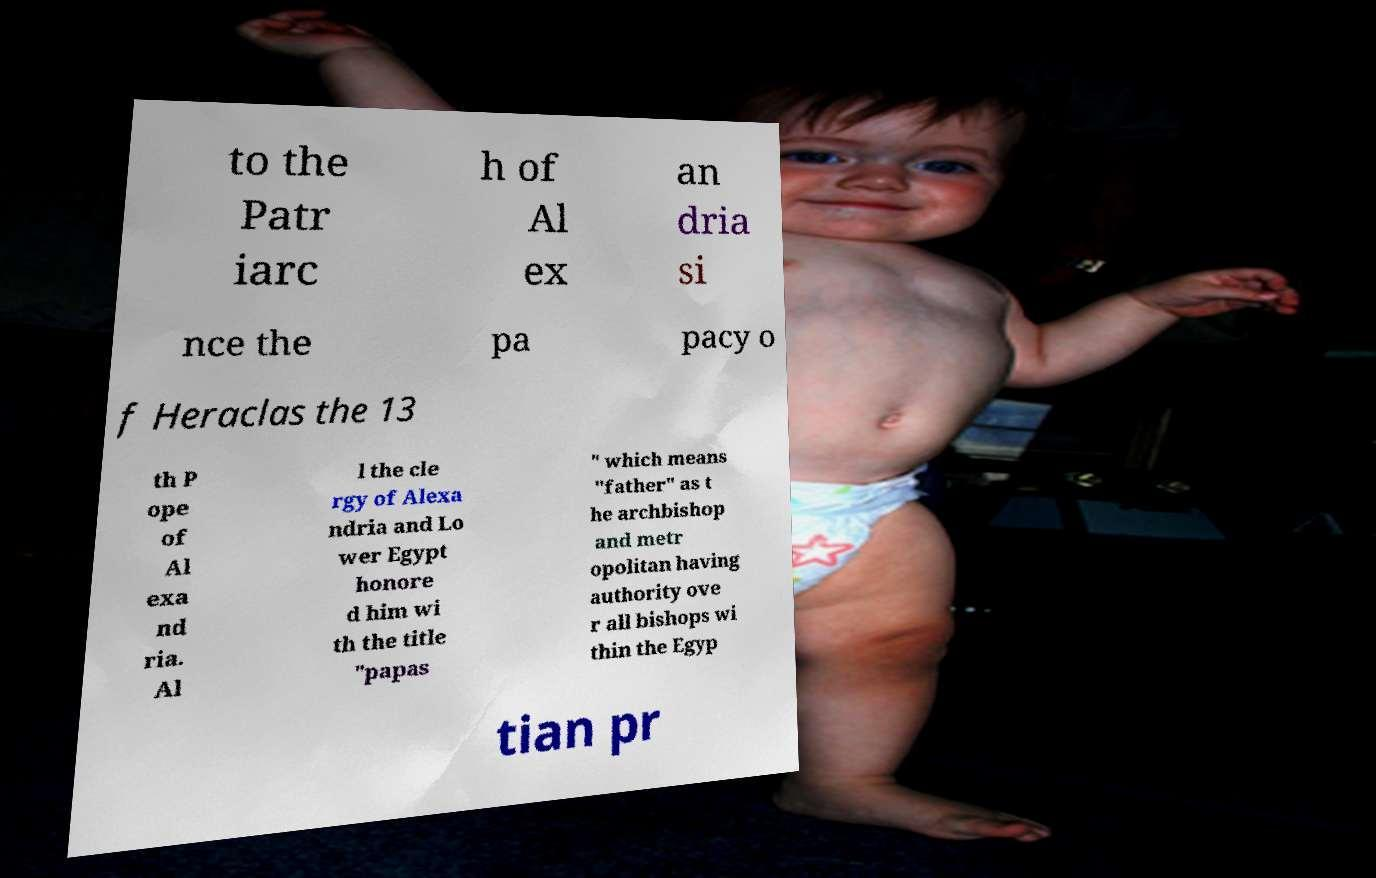Please identify and transcribe the text found in this image. to the Patr iarc h of Al ex an dria si nce the pa pacy o f Heraclas the 13 th P ope of Al exa nd ria. Al l the cle rgy of Alexa ndria and Lo wer Egypt honore d him wi th the title "papas " which means "father" as t he archbishop and metr opolitan having authority ove r all bishops wi thin the Egyp tian pr 